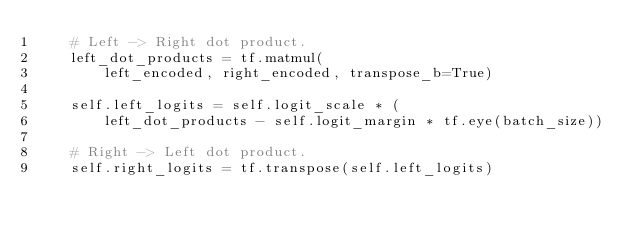<code> <loc_0><loc_0><loc_500><loc_500><_Python_>    # Left -> Right dot product.
    left_dot_products = tf.matmul(
        left_encoded, right_encoded, transpose_b=True)

    self.left_logits = self.logit_scale * (
        left_dot_products - self.logit_margin * tf.eye(batch_size))

    # Right -> Left dot product.
    self.right_logits = tf.transpose(self.left_logits)
</code> 